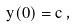Convert formula to latex. <formula><loc_0><loc_0><loc_500><loc_500>y ( 0 ) = c \, ,</formula> 